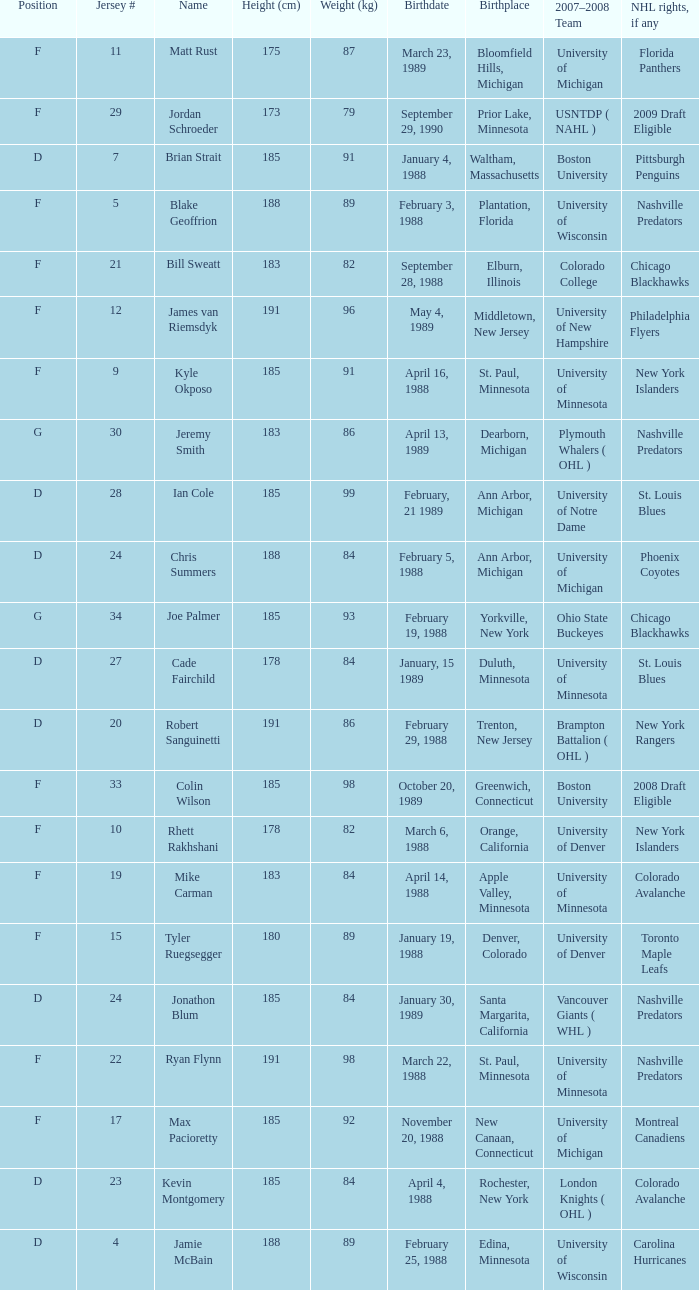Which Height (cm) has a Birthplace of new canaan, connecticut? 1.0. 